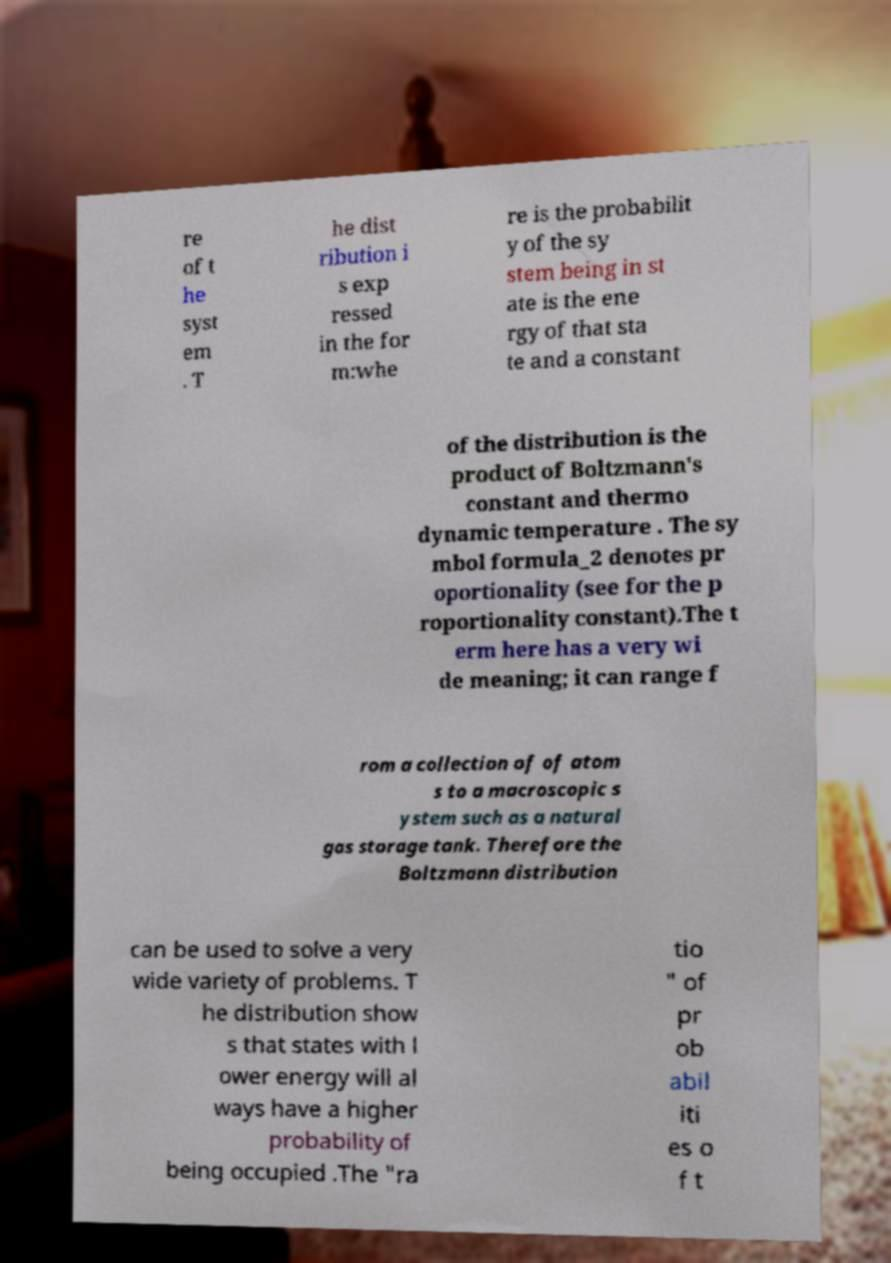There's text embedded in this image that I need extracted. Can you transcribe it verbatim? re of t he syst em . T he dist ribution i s exp ressed in the for m:whe re is the probabilit y of the sy stem being in st ate is the ene rgy of that sta te and a constant of the distribution is the product of Boltzmann's constant and thermo dynamic temperature . The sy mbol formula_2 denotes pr oportionality (see for the p roportionality constant).The t erm here has a very wi de meaning; it can range f rom a collection of of atom s to a macroscopic s ystem such as a natural gas storage tank. Therefore the Boltzmann distribution can be used to solve a very wide variety of problems. T he distribution show s that states with l ower energy will al ways have a higher probability of being occupied .The "ra tio " of pr ob abil iti es o f t 